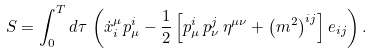<formula> <loc_0><loc_0><loc_500><loc_500>S = \int _ { 0 } ^ { T } d \tau \, \left ( \dot { x } _ { i } ^ { \mu } p _ { \mu } ^ { i } - \frac { 1 } { 2 } \left [ p _ { \mu } ^ { i } \, p _ { \nu } ^ { j } \, \eta ^ { \mu \nu } + \left ( m ^ { 2 } \right ) ^ { i j } \right ] e _ { i j } \right ) .</formula> 